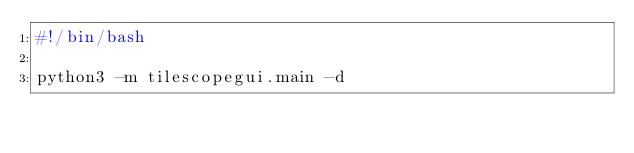<code> <loc_0><loc_0><loc_500><loc_500><_Bash_>#!/bin/bash

python3 -m tilescopegui.main -d
</code> 